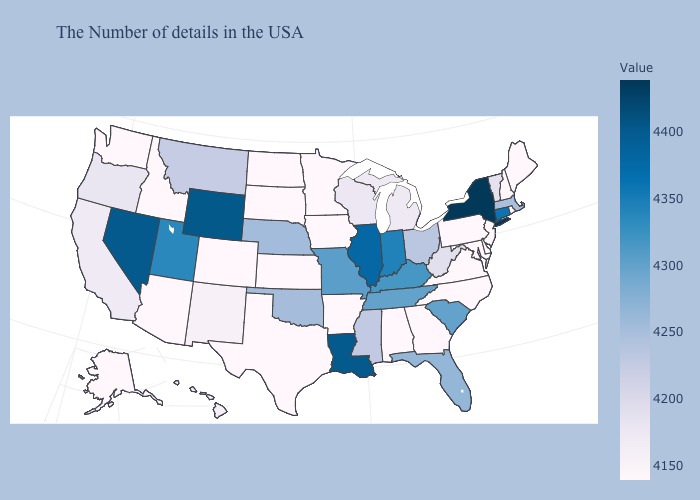Which states have the lowest value in the South?
Keep it brief. Delaware, Maryland, Virginia, North Carolina, Georgia, Alabama, Arkansas, Texas. Does Alaska have the highest value in the USA?
Quick response, please. No. Among the states that border Oregon , does Washington have the lowest value?
Concise answer only. Yes. Among the states that border New York , does Pennsylvania have the highest value?
Concise answer only. No. Does New Mexico have the lowest value in the West?
Keep it brief. No. Which states hav the highest value in the South?
Concise answer only. Louisiana. 